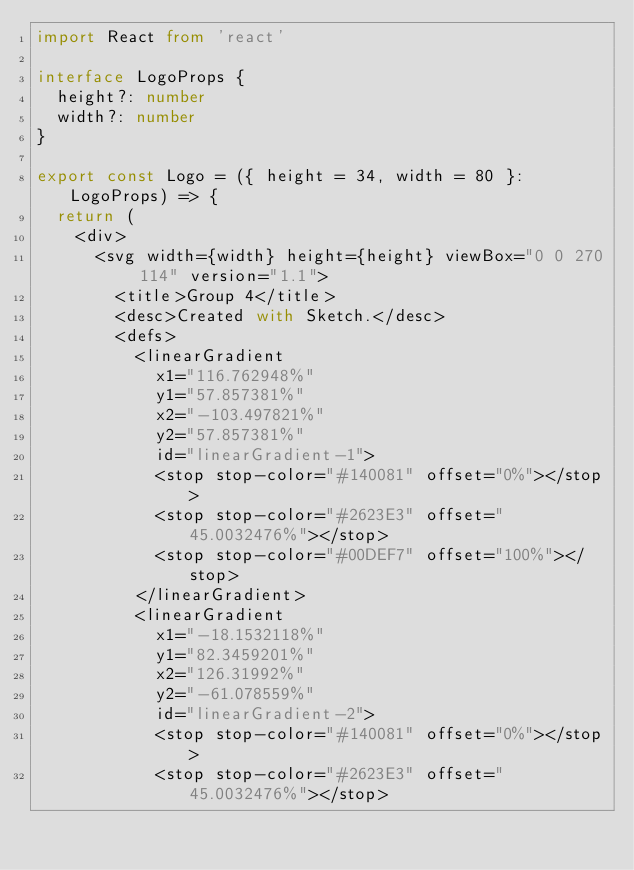<code> <loc_0><loc_0><loc_500><loc_500><_TypeScript_>import React from 'react'

interface LogoProps {
  height?: number
  width?: number
}

export const Logo = ({ height = 34, width = 80 }: LogoProps) => {
  return (
    <div>
      <svg width={width} height={height} viewBox="0 0 270 114" version="1.1">
        <title>Group 4</title>
        <desc>Created with Sketch.</desc>
        <defs>
          <linearGradient
            x1="116.762948%"
            y1="57.857381%"
            x2="-103.497821%"
            y2="57.857381%"
            id="linearGradient-1">
            <stop stop-color="#140081" offset="0%"></stop>
            <stop stop-color="#2623E3" offset="45.0032476%"></stop>
            <stop stop-color="#00DEF7" offset="100%"></stop>
          </linearGradient>
          <linearGradient
            x1="-18.1532118%"
            y1="82.3459201%"
            x2="126.31992%"
            y2="-61.078559%"
            id="linearGradient-2">
            <stop stop-color="#140081" offset="0%"></stop>
            <stop stop-color="#2623E3" offset="45.0032476%"></stop></code> 